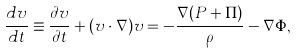Convert formula to latex. <formula><loc_0><loc_0><loc_500><loc_500>\frac { d { v } } { d t } \equiv \frac { \partial { v } } { \partial t } + ( { v } \cdot { \nabla } ) { v } = - \frac { { \nabla } ( P + \Pi ) } { \rho } - { \nabla } \Phi ,</formula> 